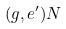<formula> <loc_0><loc_0><loc_500><loc_500>( g , e ^ { \prime } ) N</formula> 